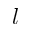<formula> <loc_0><loc_0><loc_500><loc_500>l</formula> 